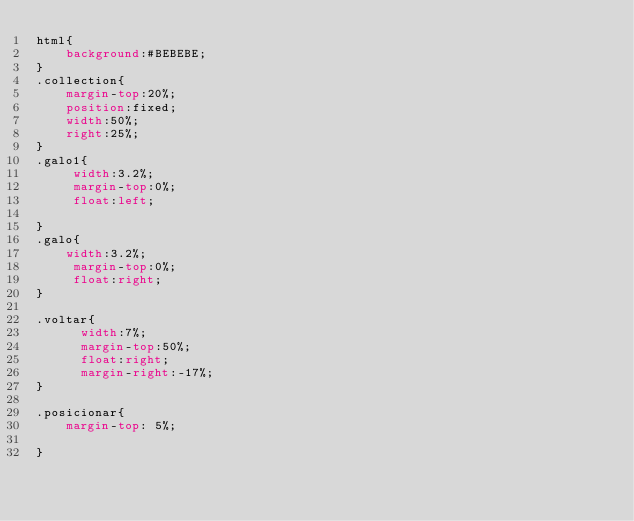<code> <loc_0><loc_0><loc_500><loc_500><_CSS_>html{
	background:#BEBEBE;
}
.collection{
	margin-top:20%;
	position:fixed;
	width:50%;
	right:25%;
}
.galo1{
	 width:3.2%;
	 margin-top:0%;
	 float:left;
	
}
.galo{
	width:3.2%;
	 margin-top:0%;
	 float:right;
}

.voltar{
      width:7%;
	  margin-top:50%;
	  float:right;
	  margin-right:-17%;
}	

.posicionar{
	margin-top: 5%;
	
}  
</code> 